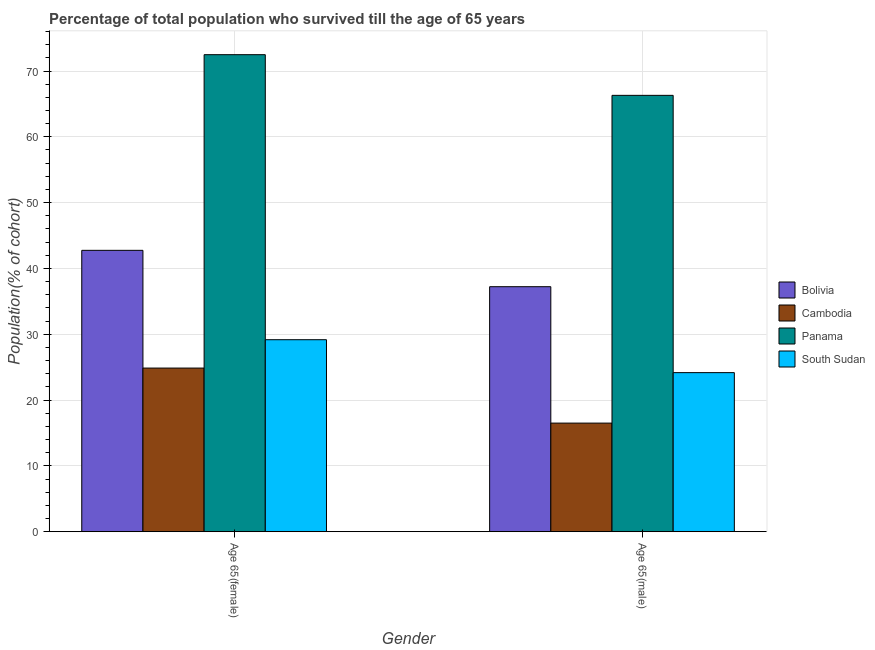How many groups of bars are there?
Offer a terse response. 2. How many bars are there on the 2nd tick from the right?
Keep it short and to the point. 4. What is the label of the 2nd group of bars from the left?
Ensure brevity in your answer.  Age 65(male). What is the percentage of male population who survived till age of 65 in South Sudan?
Make the answer very short. 24.17. Across all countries, what is the maximum percentage of male population who survived till age of 65?
Provide a succinct answer. 66.3. Across all countries, what is the minimum percentage of male population who survived till age of 65?
Give a very brief answer. 16.5. In which country was the percentage of male population who survived till age of 65 maximum?
Provide a short and direct response. Panama. In which country was the percentage of male population who survived till age of 65 minimum?
Make the answer very short. Cambodia. What is the total percentage of male population who survived till age of 65 in the graph?
Provide a short and direct response. 144.2. What is the difference between the percentage of female population who survived till age of 65 in Cambodia and that in South Sudan?
Make the answer very short. -4.31. What is the difference between the percentage of female population who survived till age of 65 in Cambodia and the percentage of male population who survived till age of 65 in South Sudan?
Your response must be concise. 0.69. What is the average percentage of female population who survived till age of 65 per country?
Provide a succinct answer. 42.32. What is the difference between the percentage of male population who survived till age of 65 and percentage of female population who survived till age of 65 in Panama?
Your answer should be compact. -6.18. What is the ratio of the percentage of female population who survived till age of 65 in Panama to that in Bolivia?
Provide a succinct answer. 1.7. In how many countries, is the percentage of female population who survived till age of 65 greater than the average percentage of female population who survived till age of 65 taken over all countries?
Your response must be concise. 2. What does the 2nd bar from the right in Age 65(female) represents?
Offer a terse response. Panama. How many bars are there?
Ensure brevity in your answer.  8. Are all the bars in the graph horizontal?
Keep it short and to the point. No. How many countries are there in the graph?
Ensure brevity in your answer.  4. Where does the legend appear in the graph?
Give a very brief answer. Center right. How are the legend labels stacked?
Offer a terse response. Vertical. What is the title of the graph?
Provide a short and direct response. Percentage of total population who survived till the age of 65 years. Does "Nepal" appear as one of the legend labels in the graph?
Offer a terse response. No. What is the label or title of the Y-axis?
Provide a succinct answer. Population(% of cohort). What is the Population(% of cohort) of Bolivia in Age 65(female)?
Offer a terse response. 42.75. What is the Population(% of cohort) of Cambodia in Age 65(female)?
Your answer should be compact. 24.86. What is the Population(% of cohort) in Panama in Age 65(female)?
Provide a short and direct response. 72.48. What is the Population(% of cohort) in South Sudan in Age 65(female)?
Provide a succinct answer. 29.17. What is the Population(% of cohort) in Bolivia in Age 65(male)?
Offer a very short reply. 37.23. What is the Population(% of cohort) of Cambodia in Age 65(male)?
Your response must be concise. 16.5. What is the Population(% of cohort) in Panama in Age 65(male)?
Keep it short and to the point. 66.3. What is the Population(% of cohort) in South Sudan in Age 65(male)?
Offer a very short reply. 24.17. Across all Gender, what is the maximum Population(% of cohort) of Bolivia?
Provide a short and direct response. 42.75. Across all Gender, what is the maximum Population(% of cohort) in Cambodia?
Your response must be concise. 24.86. Across all Gender, what is the maximum Population(% of cohort) of Panama?
Offer a terse response. 72.48. Across all Gender, what is the maximum Population(% of cohort) in South Sudan?
Provide a succinct answer. 29.17. Across all Gender, what is the minimum Population(% of cohort) of Bolivia?
Offer a very short reply. 37.23. Across all Gender, what is the minimum Population(% of cohort) of Cambodia?
Your response must be concise. 16.5. Across all Gender, what is the minimum Population(% of cohort) of Panama?
Offer a terse response. 66.3. Across all Gender, what is the minimum Population(% of cohort) in South Sudan?
Ensure brevity in your answer.  24.17. What is the total Population(% of cohort) of Bolivia in the graph?
Make the answer very short. 79.98. What is the total Population(% of cohort) in Cambodia in the graph?
Your answer should be very brief. 41.36. What is the total Population(% of cohort) of Panama in the graph?
Your response must be concise. 138.78. What is the total Population(% of cohort) of South Sudan in the graph?
Provide a short and direct response. 53.34. What is the difference between the Population(% of cohort) in Bolivia in Age 65(female) and that in Age 65(male)?
Your answer should be very brief. 5.52. What is the difference between the Population(% of cohort) in Cambodia in Age 65(female) and that in Age 65(male)?
Your answer should be very brief. 8.36. What is the difference between the Population(% of cohort) in Panama in Age 65(female) and that in Age 65(male)?
Provide a short and direct response. 6.18. What is the difference between the Population(% of cohort) of South Sudan in Age 65(female) and that in Age 65(male)?
Your response must be concise. 5. What is the difference between the Population(% of cohort) in Bolivia in Age 65(female) and the Population(% of cohort) in Cambodia in Age 65(male)?
Your answer should be compact. 26.25. What is the difference between the Population(% of cohort) of Bolivia in Age 65(female) and the Population(% of cohort) of Panama in Age 65(male)?
Keep it short and to the point. -23.55. What is the difference between the Population(% of cohort) of Bolivia in Age 65(female) and the Population(% of cohort) of South Sudan in Age 65(male)?
Provide a succinct answer. 18.58. What is the difference between the Population(% of cohort) of Cambodia in Age 65(female) and the Population(% of cohort) of Panama in Age 65(male)?
Give a very brief answer. -41.44. What is the difference between the Population(% of cohort) of Cambodia in Age 65(female) and the Population(% of cohort) of South Sudan in Age 65(male)?
Give a very brief answer. 0.69. What is the difference between the Population(% of cohort) in Panama in Age 65(female) and the Population(% of cohort) in South Sudan in Age 65(male)?
Make the answer very short. 48.31. What is the average Population(% of cohort) of Bolivia per Gender?
Offer a very short reply. 39.99. What is the average Population(% of cohort) of Cambodia per Gender?
Your answer should be compact. 20.68. What is the average Population(% of cohort) of Panama per Gender?
Provide a short and direct response. 69.39. What is the average Population(% of cohort) in South Sudan per Gender?
Make the answer very short. 26.67. What is the difference between the Population(% of cohort) of Bolivia and Population(% of cohort) of Cambodia in Age 65(female)?
Give a very brief answer. 17.89. What is the difference between the Population(% of cohort) in Bolivia and Population(% of cohort) in Panama in Age 65(female)?
Make the answer very short. -29.73. What is the difference between the Population(% of cohort) in Bolivia and Population(% of cohort) in South Sudan in Age 65(female)?
Your answer should be compact. 13.58. What is the difference between the Population(% of cohort) in Cambodia and Population(% of cohort) in Panama in Age 65(female)?
Your response must be concise. -47.62. What is the difference between the Population(% of cohort) in Cambodia and Population(% of cohort) in South Sudan in Age 65(female)?
Give a very brief answer. -4.31. What is the difference between the Population(% of cohort) of Panama and Population(% of cohort) of South Sudan in Age 65(female)?
Provide a succinct answer. 43.31. What is the difference between the Population(% of cohort) of Bolivia and Population(% of cohort) of Cambodia in Age 65(male)?
Offer a very short reply. 20.73. What is the difference between the Population(% of cohort) of Bolivia and Population(% of cohort) of Panama in Age 65(male)?
Make the answer very short. -29.07. What is the difference between the Population(% of cohort) of Bolivia and Population(% of cohort) of South Sudan in Age 65(male)?
Make the answer very short. 13.06. What is the difference between the Population(% of cohort) in Cambodia and Population(% of cohort) in Panama in Age 65(male)?
Your response must be concise. -49.8. What is the difference between the Population(% of cohort) of Cambodia and Population(% of cohort) of South Sudan in Age 65(male)?
Keep it short and to the point. -7.67. What is the difference between the Population(% of cohort) of Panama and Population(% of cohort) of South Sudan in Age 65(male)?
Provide a short and direct response. 42.13. What is the ratio of the Population(% of cohort) in Bolivia in Age 65(female) to that in Age 65(male)?
Your answer should be very brief. 1.15. What is the ratio of the Population(% of cohort) of Cambodia in Age 65(female) to that in Age 65(male)?
Offer a terse response. 1.51. What is the ratio of the Population(% of cohort) in Panama in Age 65(female) to that in Age 65(male)?
Offer a very short reply. 1.09. What is the ratio of the Population(% of cohort) in South Sudan in Age 65(female) to that in Age 65(male)?
Make the answer very short. 1.21. What is the difference between the highest and the second highest Population(% of cohort) of Bolivia?
Keep it short and to the point. 5.52. What is the difference between the highest and the second highest Population(% of cohort) in Cambodia?
Your response must be concise. 8.36. What is the difference between the highest and the second highest Population(% of cohort) in Panama?
Offer a very short reply. 6.18. What is the difference between the highest and the second highest Population(% of cohort) of South Sudan?
Your answer should be compact. 5. What is the difference between the highest and the lowest Population(% of cohort) of Bolivia?
Offer a very short reply. 5.52. What is the difference between the highest and the lowest Population(% of cohort) of Cambodia?
Ensure brevity in your answer.  8.36. What is the difference between the highest and the lowest Population(% of cohort) in Panama?
Provide a succinct answer. 6.18. What is the difference between the highest and the lowest Population(% of cohort) of South Sudan?
Make the answer very short. 5. 